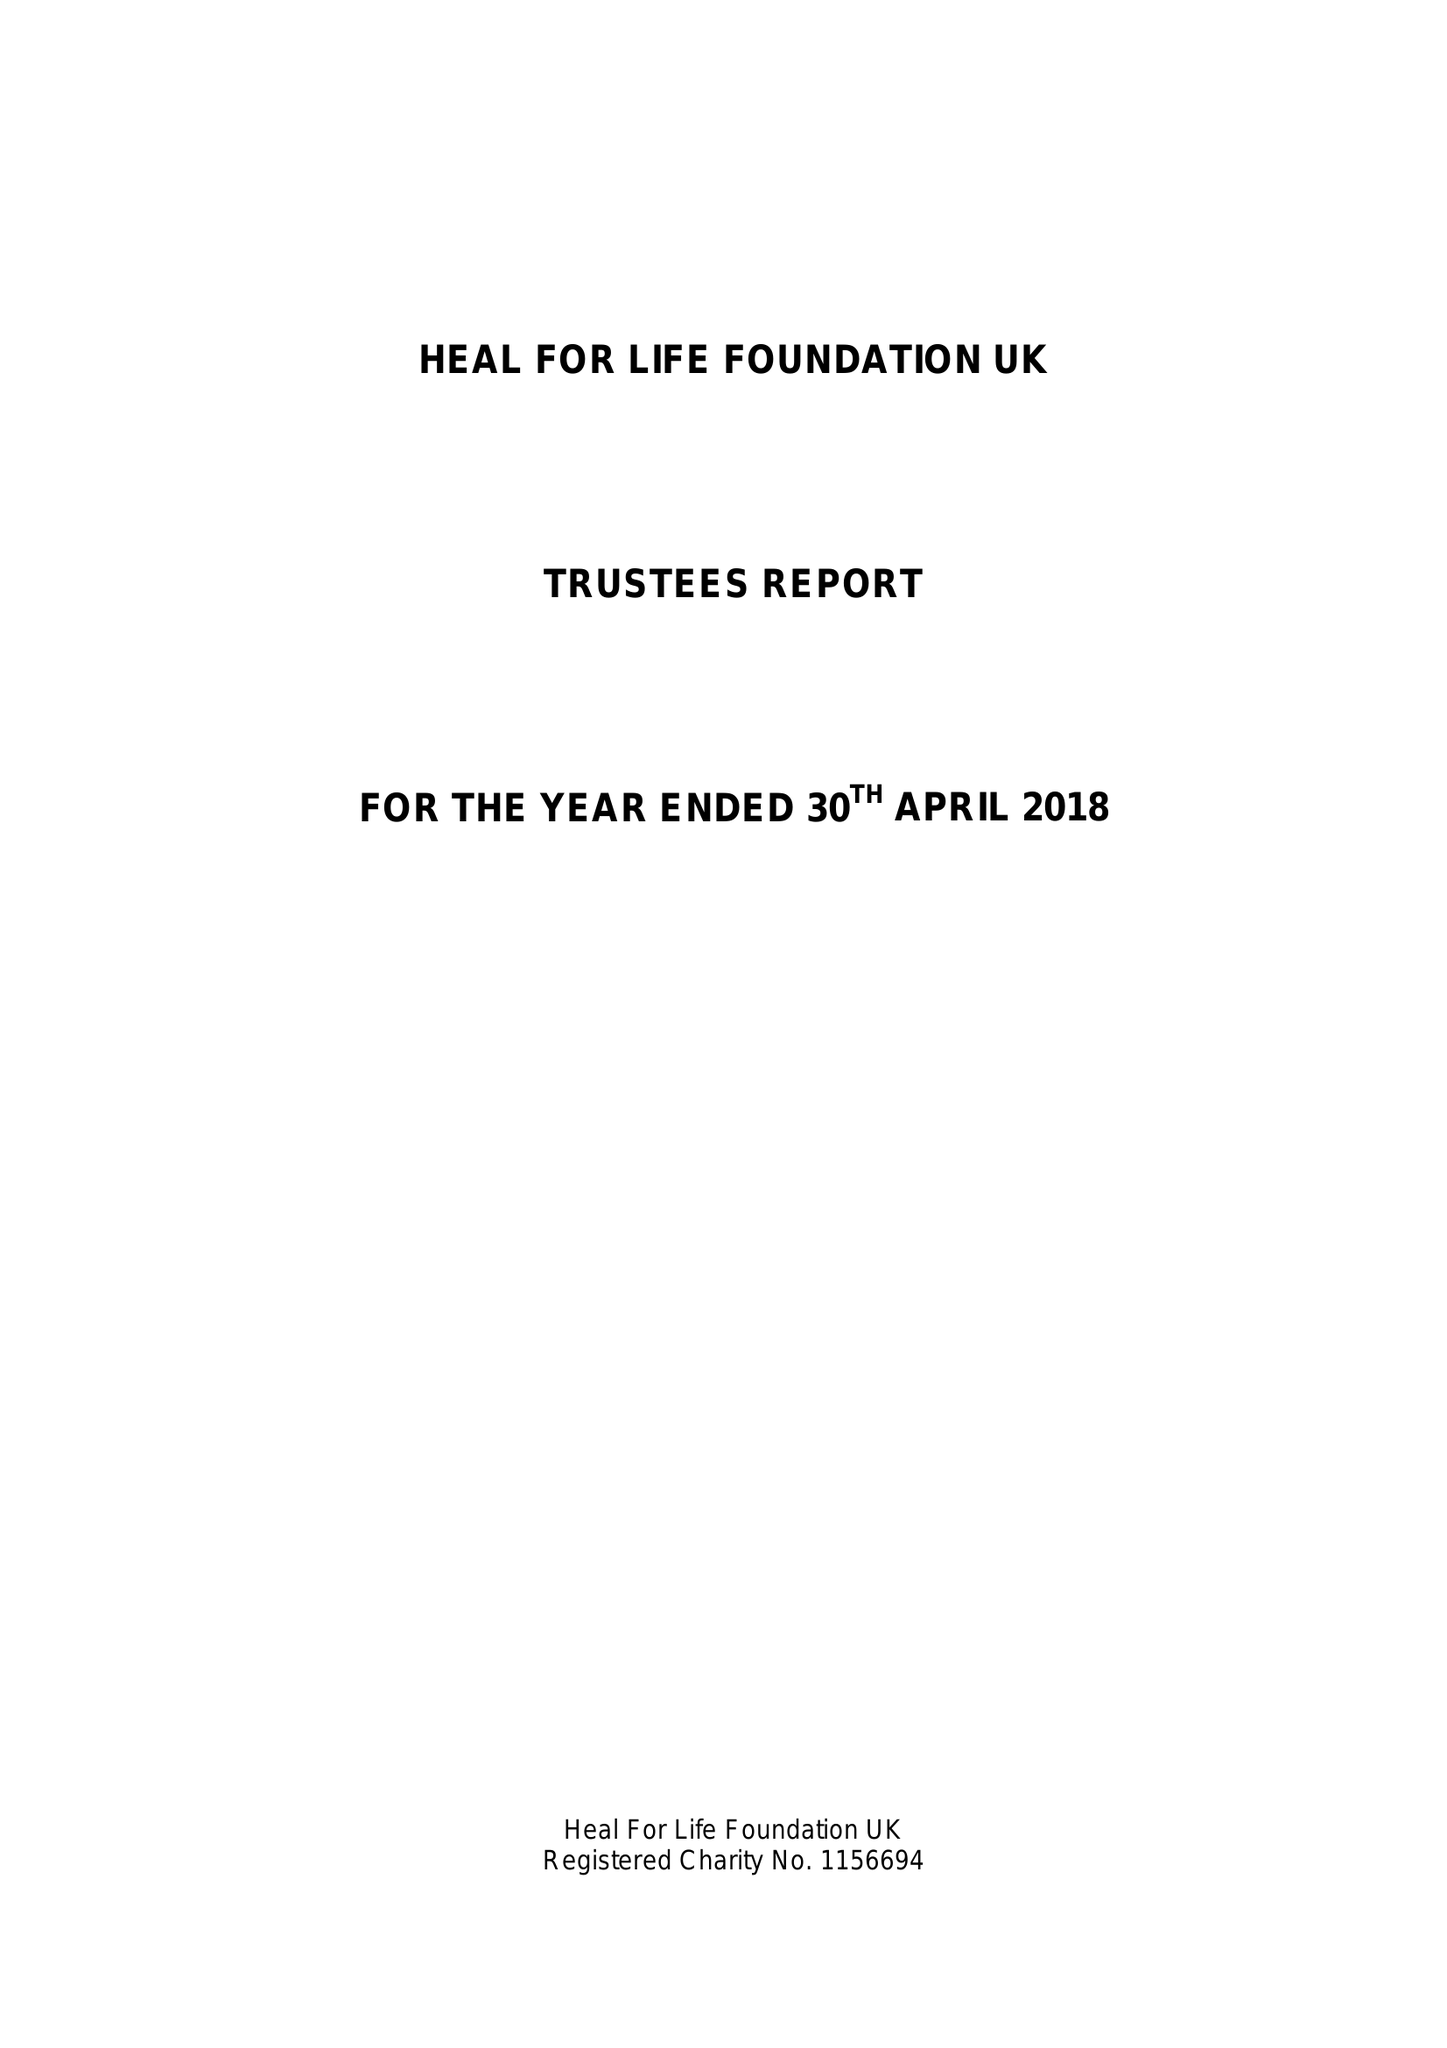What is the value for the charity_name?
Answer the question using a single word or phrase. Heal For Life Foundation Uk 